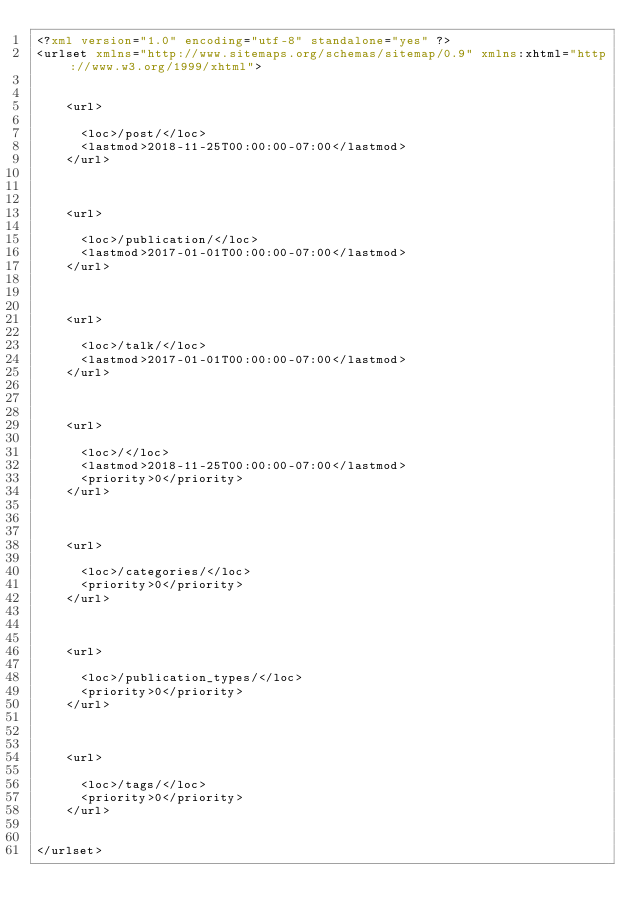<code> <loc_0><loc_0><loc_500><loc_500><_XML_><?xml version="1.0" encoding="utf-8" standalone="yes" ?>
<urlset xmlns="http://www.sitemaps.org/schemas/sitemap/0.9" xmlns:xhtml="http://www.w3.org/1999/xhtml">
  
    
    <url>
    
      <loc>/post/</loc>
      <lastmod>2018-11-25T00:00:00-07:00</lastmod>
    </url>
    
  
    
    <url>
    
      <loc>/publication/</loc>
      <lastmod>2017-01-01T00:00:00-07:00</lastmod>
    </url>
    
  
    
    <url>
    
      <loc>/talk/</loc>
      <lastmod>2017-01-01T00:00:00-07:00</lastmod>
    </url>
    
  
    
    <url>
    
      <loc>/</loc>
      <lastmod>2018-11-25T00:00:00-07:00</lastmod>
      <priority>0</priority>
    </url>
    
  
    
    <url>
    
      <loc>/categories/</loc>
      <priority>0</priority>
    </url>
    
  
    
    <url>
    
      <loc>/publication_types/</loc>
      <priority>0</priority>
    </url>
    
  
    
    <url>
    
      <loc>/tags/</loc>
      <priority>0</priority>
    </url>
    
  
</urlset>
</code> 